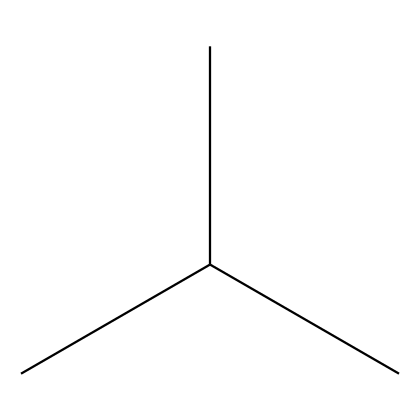What is the main component of this chemical? The chemical structure represents polypropylene, which consists of repeating propylene units in a polymer chain.
Answer: polypropylene How many carbon atoms are present in this molecule? The SMILES representation shows a total of four carbon atoms connected in a branched structure.
Answer: four What type of bond is primarily present in this polymer? The bonds between the carbon atoms in polypropylene are primarily single covalent bonds, typical for saturated hydrocarbons.
Answer: single Is this polymer likely to be flexible or rigid? Polypropylene is known for its flexibility and toughness, making it suitable for applications like weather-resistant bird baths.
Answer: flexible How does the branching affect the properties of this polymer? The branched structure of polypropylene contributes to its lower density and improved impact resistance compared to linear forms of polypropylene.
Answer: enhances impact resistance 